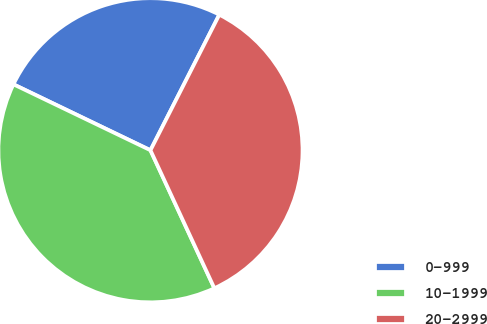Convert chart. <chart><loc_0><loc_0><loc_500><loc_500><pie_chart><fcel>0-999<fcel>10-1999<fcel>20-2999<nl><fcel>25.34%<fcel>39.04%<fcel>35.62%<nl></chart> 